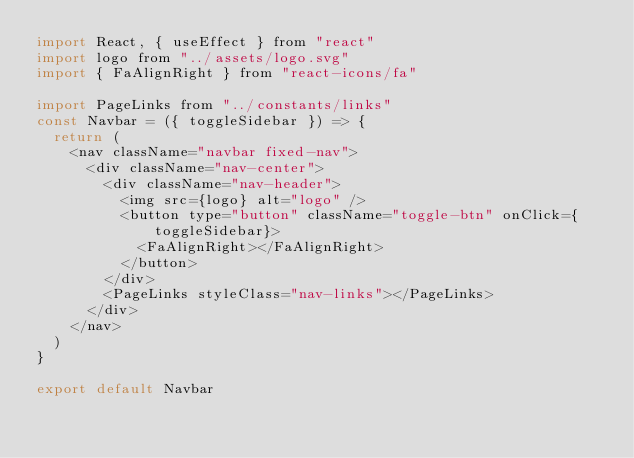<code> <loc_0><loc_0><loc_500><loc_500><_JavaScript_>import React, { useEffect } from "react"
import logo from "../assets/logo.svg"
import { FaAlignRight } from "react-icons/fa"

import PageLinks from "../constants/links"
const Navbar = ({ toggleSidebar }) => {
  return (
    <nav className="navbar fixed-nav">
      <div className="nav-center">
        <div className="nav-header">
          <img src={logo} alt="logo" />
          <button type="button" className="toggle-btn" onClick={toggleSidebar}>
            <FaAlignRight></FaAlignRight>
          </button>
        </div>
        <PageLinks styleClass="nav-links"></PageLinks>
      </div>
    </nav>
  )
}

export default Navbar
</code> 